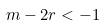Convert formula to latex. <formula><loc_0><loc_0><loc_500><loc_500>m - 2 r < - 1</formula> 